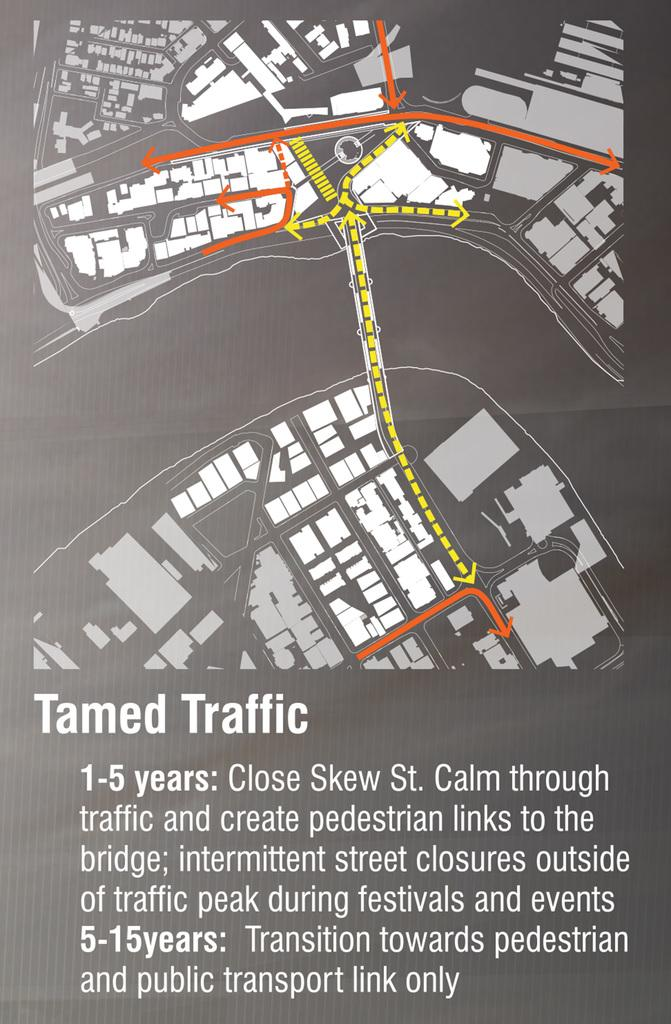<image>
Write a terse but informative summary of the picture. Map or sketch showing "tamed traffic" in grey and white. 